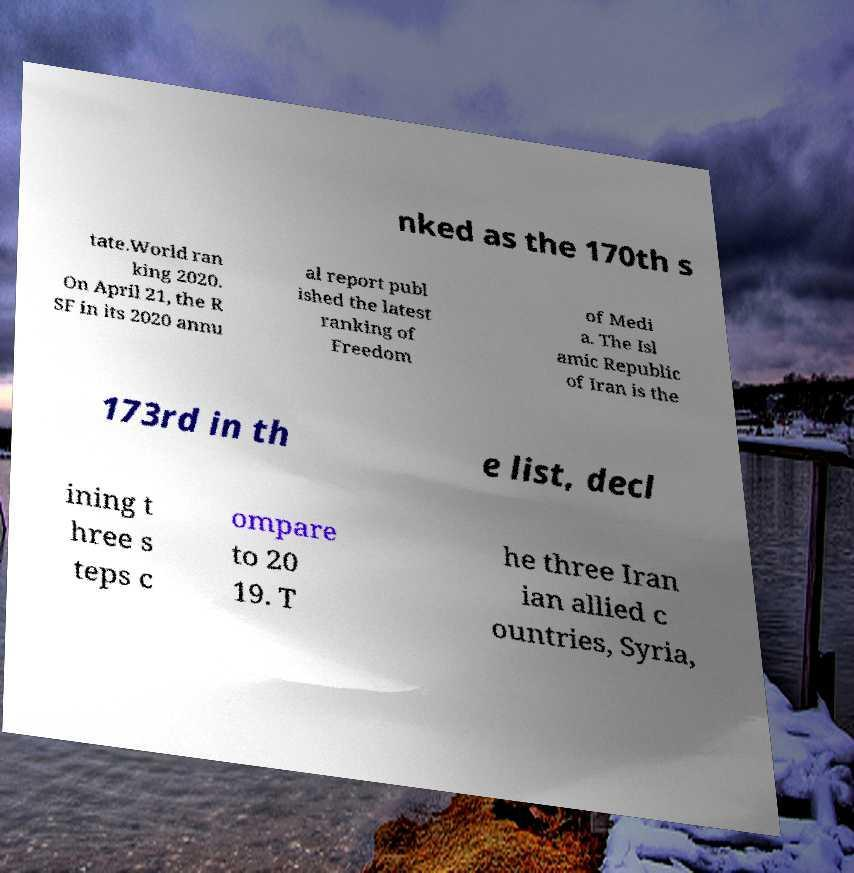There's text embedded in this image that I need extracted. Can you transcribe it verbatim? nked as the 170th s tate.World ran king 2020. On April 21, the R SF in its 2020 annu al report publ ished the latest ranking of Freedom of Medi a. The Isl amic Republic of Iran is the 173rd in th e list, decl ining t hree s teps c ompare to 20 19. T he three Iran ian allied c ountries, Syria, 